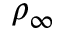<formula> <loc_0><loc_0><loc_500><loc_500>\rho _ { \infty }</formula> 